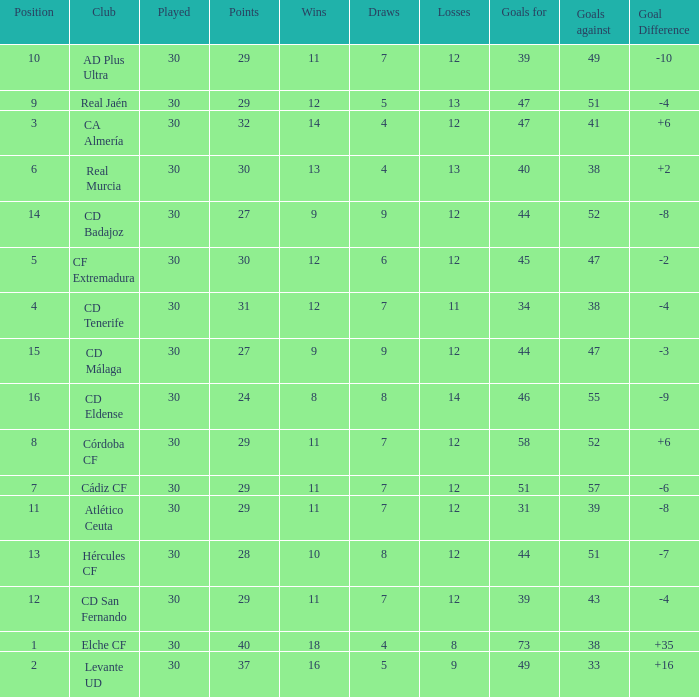What is the highest amount of goals with more than 51 goals against and less than 30 played? None. 